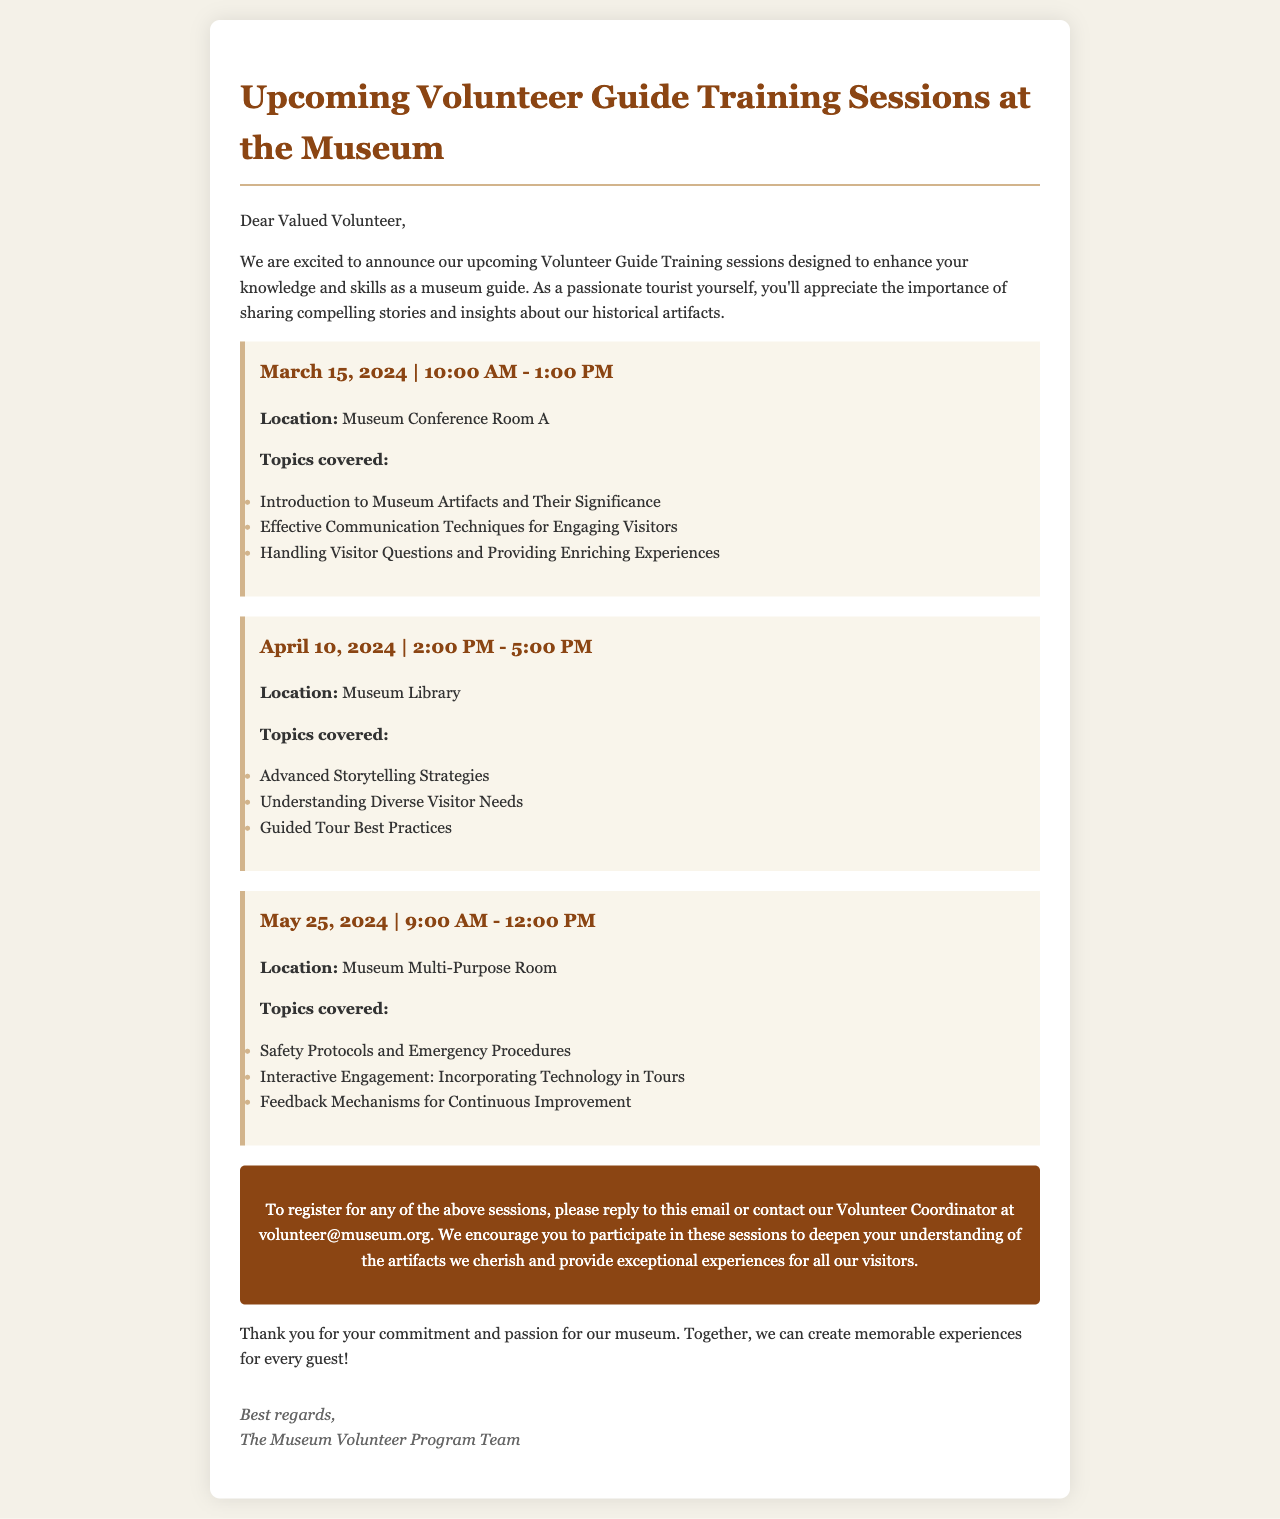what is the date of the first training session? The first training session is scheduled for March 15, 2024.
Answer: March 15, 2024 what time does the April training session start? The April training session starts at 2:00 PM.
Answer: 2:00 PM how many topics are covered in the May training session? The May training session covers three topics.
Answer: three where is the March training session held? The March training session is held in Museum Conference Room A.
Answer: Museum Conference Room A what is the main focus of the April training session? The main focus of the April training session is on advanced storytelling strategies.
Answer: advanced storytelling strategies who should be contacted for registration? The contact for registration is the Volunteer Coordinator.
Answer: Volunteer Coordinator what feedback approach is mentioned for improvement? The document mentions feedback mechanisms for continuous improvement.
Answer: feedback mechanisms what is the duration of the May training session? The duration of the May training session is three hours.
Answer: three hours how often are the training sessions taking place as per the document? The training sessions are taking place once a month.
Answer: once a month 